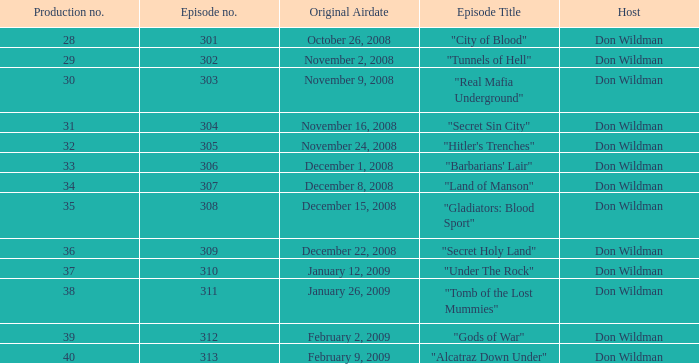What is the episode number of the episode that premiered on january 26, 2009 and had a production number beneath 38? 0.0. 